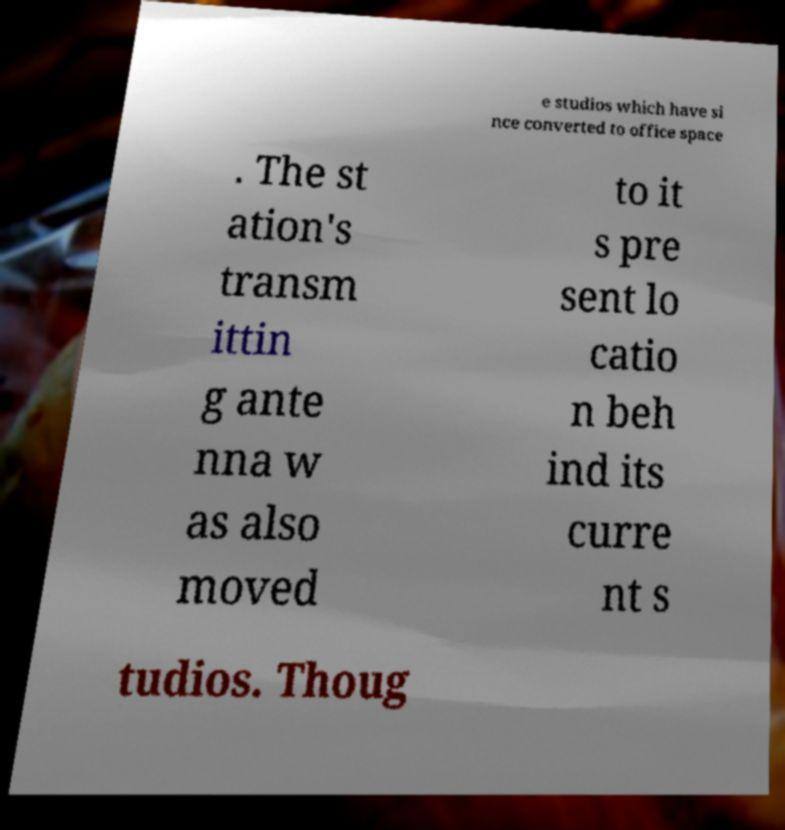For documentation purposes, I need the text within this image transcribed. Could you provide that? e studios which have si nce converted to office space . The st ation's transm ittin g ante nna w as also moved to it s pre sent lo catio n beh ind its curre nt s tudios. Thoug 